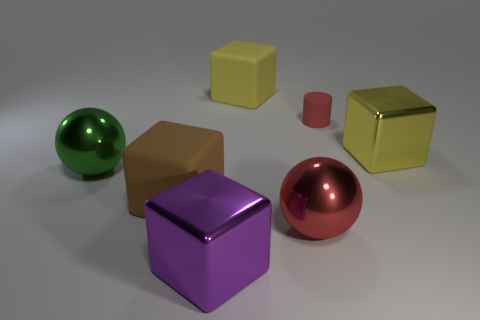Subtract all purple blocks. How many blocks are left? 3 Add 2 large red metal things. How many objects exist? 9 Subtract all cyan blocks. Subtract all gray cylinders. How many blocks are left? 4 Subtract all cylinders. How many objects are left? 6 Add 2 small rubber cylinders. How many small rubber cylinders exist? 3 Subtract 0 green cylinders. How many objects are left? 7 Subtract all matte balls. Subtract all big yellow shiny things. How many objects are left? 6 Add 1 red metallic objects. How many red metallic objects are left? 2 